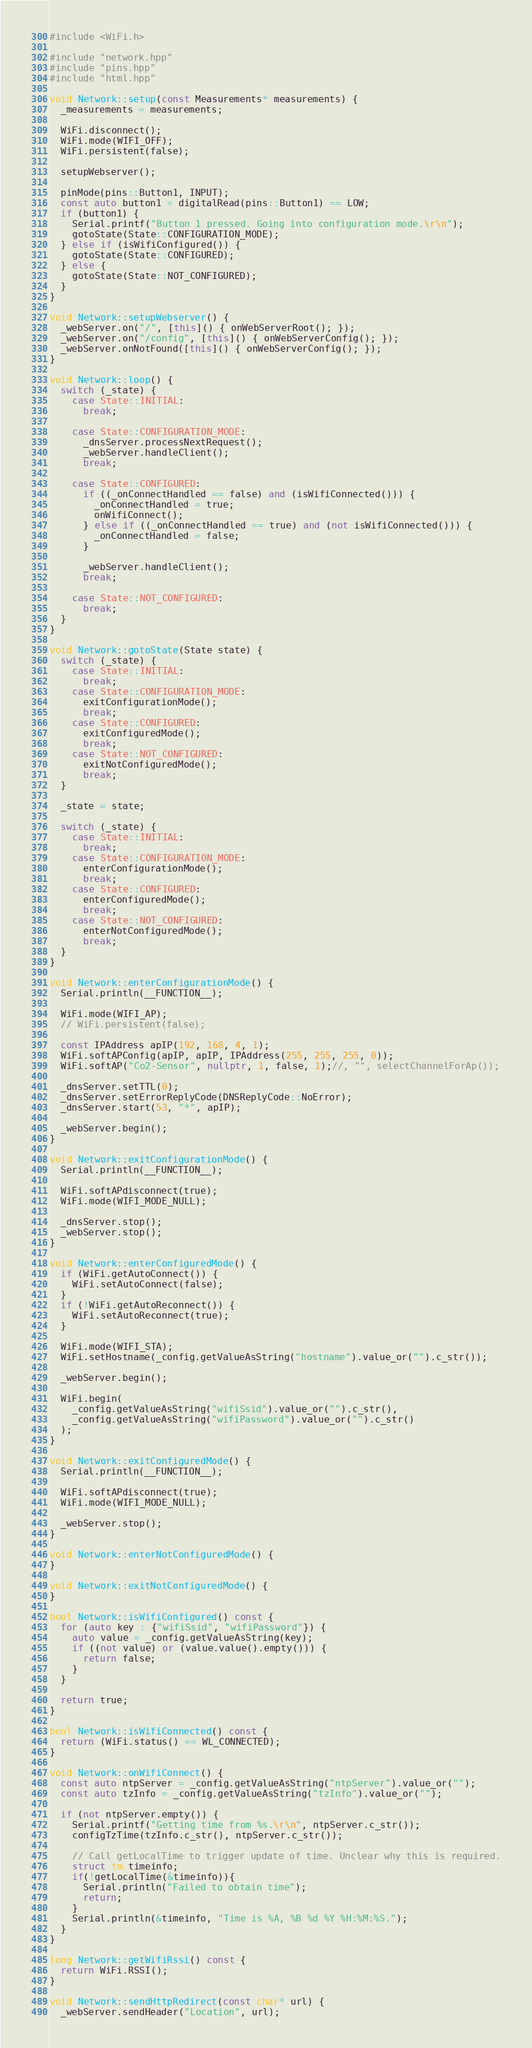<code> <loc_0><loc_0><loc_500><loc_500><_C++_>#include <WiFi.h>

#include "network.hpp"
#include "pins.hpp"
#include "html.hpp"

void Network::setup(const Measurements* measurements) {
  _measurements = measurements;

  WiFi.disconnect();
  WiFi.mode(WIFI_OFF);
  WiFi.persistent(false);

  setupWebserver();

  pinMode(pins::Button1, INPUT);
  const auto button1 = digitalRead(pins::Button1) == LOW;
  if (button1) {
    Serial.printf("Button 1 pressed. Going into configuration mode.\r\n");
    gotoState(State::CONFIGURATION_MODE);
  } else if (isWifiConfigured()) {
    gotoState(State::CONFIGURED);
  } else {
    gotoState(State::NOT_CONFIGURED);
  }
}

void Network::setupWebserver() {
  _webServer.on("/", [this]() { onWebServerRoot(); });
  _webServer.on("/config", [this]() { onWebServerConfig(); });
  _webServer.onNotFound([this]() { onWebServerConfig(); });
}

void Network::loop() {
  switch (_state) {
    case State::INITIAL:
      break;

    case State::CONFIGURATION_MODE:
      _dnsServer.processNextRequest();
      _webServer.handleClient();
      break;

    case State::CONFIGURED:
      if ((_onConnectHandled == false) and (isWifiConnected())) {
        _onConnectHandled = true;
        onWifiConnect();
      } else if ((_onConnectHandled == true) and (not isWifiConnected())) {
        _onConnectHandled = false;
      }

      _webServer.handleClient();
      break;

    case State::NOT_CONFIGURED:
      break;
  }
}

void Network::gotoState(State state) {
  switch (_state) {
    case State::INITIAL:
      break;
    case State::CONFIGURATION_MODE:
      exitConfigurationMode();
      break;
    case State::CONFIGURED:
      exitConfiguredMode();
      break;
    case State::NOT_CONFIGURED:
      exitNotConfiguredMode();
      break;
  }

  _state = state;

  switch (_state) {
    case State::INITIAL:
      break;
    case State::CONFIGURATION_MODE:
      enterConfigurationMode();
      break;
    case State::CONFIGURED:
      enterConfiguredMode();
      break;
    case State::NOT_CONFIGURED:
      enterNotConfiguredMode();
      break;
  }
}

void Network::enterConfigurationMode() {
  Serial.println(__FUNCTION__);

  WiFi.mode(WIFI_AP);
  // WiFi.persistent(false);

  const IPAddress apIP(192, 168, 4, 1);
  WiFi.softAPConfig(apIP, apIP, IPAddress(255, 255, 255, 0));
  WiFi.softAP("Co2-Sensor", nullptr, 1, false, 1);//, "", selectChannelForAp());

  _dnsServer.setTTL(0);
  _dnsServer.setErrorReplyCode(DNSReplyCode::NoError);
  _dnsServer.start(53, "*", apIP);

  _webServer.begin();
}

void Network::exitConfigurationMode() {
  Serial.println(__FUNCTION__);

  WiFi.softAPdisconnect(true);
  WiFi.mode(WIFI_MODE_NULL);

  _dnsServer.stop();
  _webServer.stop();
}

void Network::enterConfiguredMode() {
  if (WiFi.getAutoConnect()) {
    WiFi.setAutoConnect(false);
  }
  if (!WiFi.getAutoReconnect()) {
    WiFi.setAutoReconnect(true);
  }

  WiFi.mode(WIFI_STA);
  WiFi.setHostname(_config.getValueAsString("hostname").value_or("").c_str());

  _webServer.begin();

  WiFi.begin(
    _config.getValueAsString("wifiSsid").value_or("").c_str(),
    _config.getValueAsString("wifiPassword").value_or("").c_str()
  );
}

void Network::exitConfiguredMode() {
  Serial.println(__FUNCTION__);

  WiFi.softAPdisconnect(true);
  WiFi.mode(WIFI_MODE_NULL);

  _webServer.stop();
}

void Network::enterNotConfiguredMode() {
}

void Network::exitNotConfiguredMode() {
}

bool Network::isWifiConfigured() const {
  for (auto key : {"wifiSsid", "wifiPassword"}) {
    auto value = _config.getValueAsString(key);
    if ((not value) or (value.value().empty())) {
      return false;
    }
  }

  return true;
}

bool Network::isWifiConnected() const {
  return (WiFi.status() == WL_CONNECTED);
}

void Network::onWifiConnect() {
  const auto ntpServer = _config.getValueAsString("ntpServer").value_or("");
  const auto tzInfo = _config.getValueAsString("tzInfo").value_or("");

  if (not ntpServer.empty()) {
    Serial.printf("Getting time from %s.\r\n", ntpServer.c_str());
    configTzTime(tzInfo.c_str(), ntpServer.c_str());

    // Call getLocalTime to trigger update of time. Unclear why this is required.
    struct tm timeinfo;
    if(!getLocalTime(&timeinfo)){
      Serial.println("Failed to obtain time");
      return;
    }
    Serial.println(&timeinfo, "Time is %A, %B %d %Y %H:%M:%S.");
  }
}

long Network::getWifiRssi() const {
  return WiFi.RSSI();
}

void Network::sendHttpRedirect(const char* url) {
  _webServer.sendHeader("Location", url);</code> 